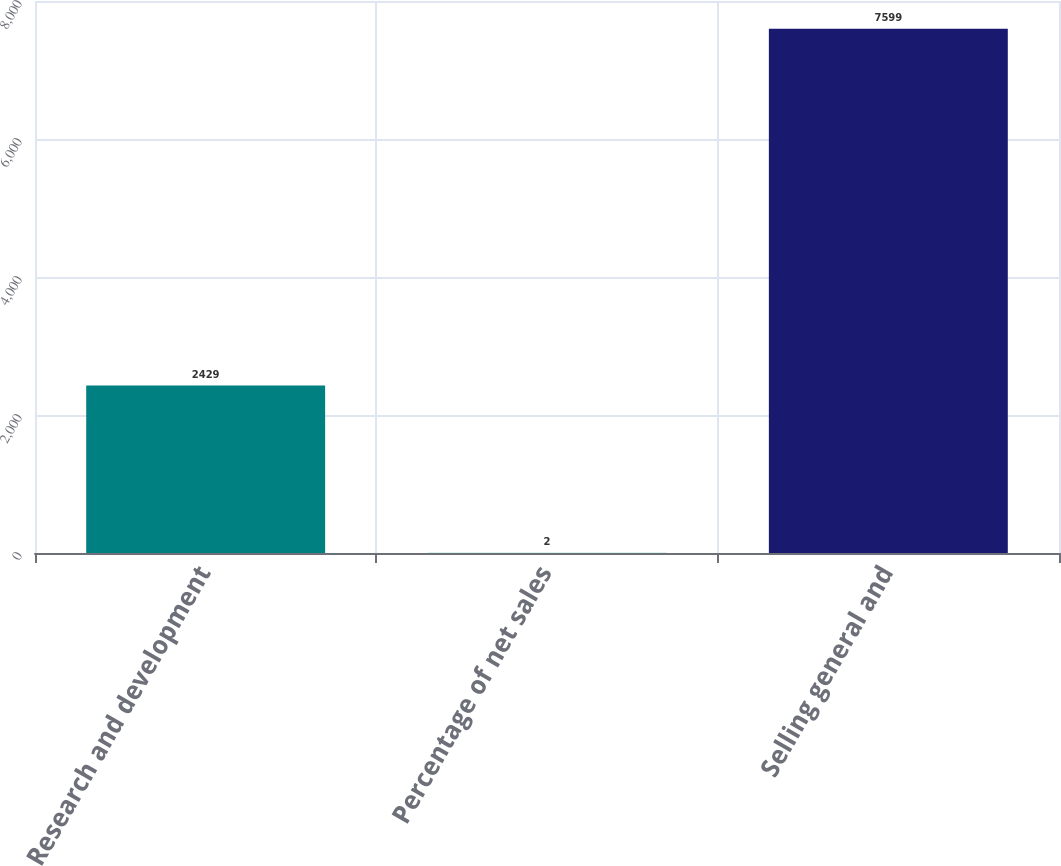<chart> <loc_0><loc_0><loc_500><loc_500><bar_chart><fcel>Research and development<fcel>Percentage of net sales<fcel>Selling general and<nl><fcel>2429<fcel>2<fcel>7599<nl></chart> 